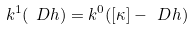<formula> <loc_0><loc_0><loc_500><loc_500>k ^ { 1 } ( \ D h ) = k ^ { 0 } ( [ \kappa ] - \ D h )</formula> 